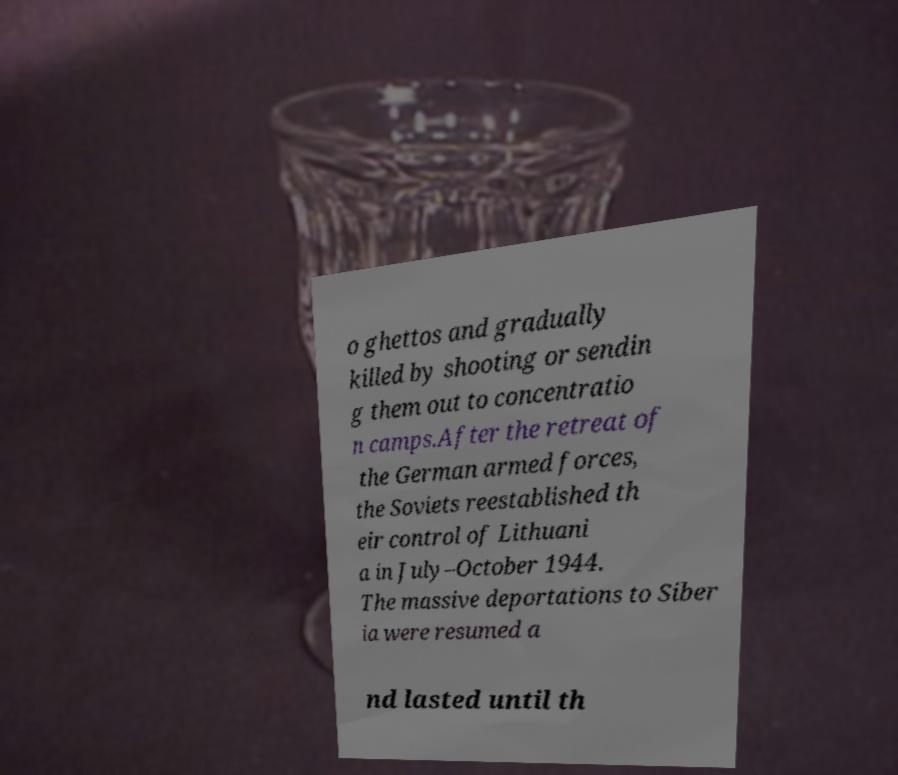For documentation purposes, I need the text within this image transcribed. Could you provide that? o ghettos and gradually killed by shooting or sendin g them out to concentratio n camps.After the retreat of the German armed forces, the Soviets reestablished th eir control of Lithuani a in July–October 1944. The massive deportations to Siber ia were resumed a nd lasted until th 